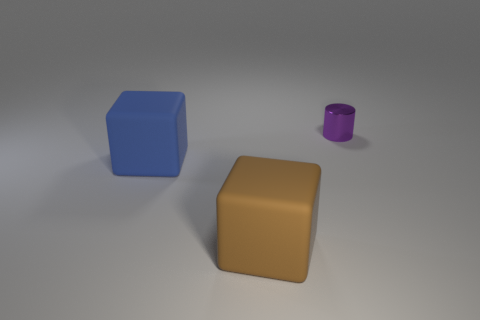Are there any small purple shiny cylinders?
Your response must be concise. Yes. There is a large matte thing that is left of the matte object that is in front of the blue rubber object; what is its shape?
Provide a succinct answer. Cube. What number of objects are large things or things that are to the right of the big blue rubber thing?
Make the answer very short. 3. The large object in front of the large matte thing on the left side of the object in front of the large blue object is what color?
Offer a very short reply. Brown. What material is the other big thing that is the same shape as the big brown rubber object?
Make the answer very short. Rubber. What is the color of the tiny thing?
Ensure brevity in your answer.  Purple. What number of matte objects are purple things or big green spheres?
Ensure brevity in your answer.  0. There is a big matte cube to the right of the cube that is behind the big brown rubber cube; is there a tiny metallic cylinder that is in front of it?
Make the answer very short. No. There is a brown block; are there any big blue matte cubes left of it?
Ensure brevity in your answer.  Yes. Are there any small cylinders right of the matte object that is on the right side of the large blue matte cube?
Your response must be concise. Yes. 